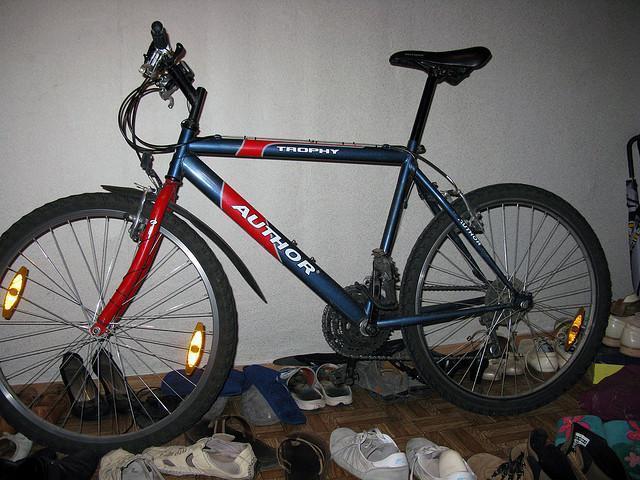How many people are visible on skis?
Give a very brief answer. 0. 